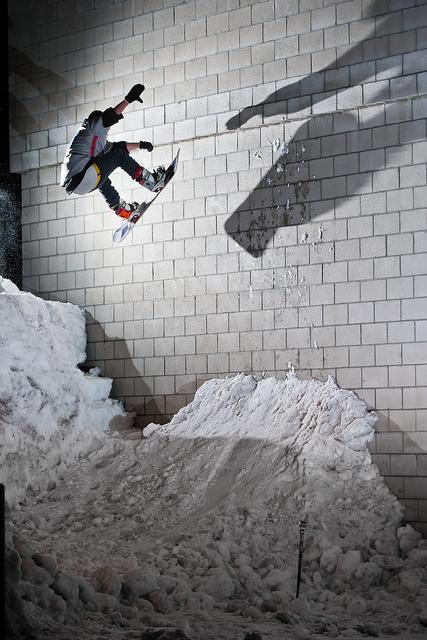Is the man going to crash into the wall?
Answer briefly. Yes. What sport is the person doing?
Concise answer only. Snowboarding. What's on the wall?
Quick response, please. Shadow. Is there loose gravel on the ground?
Be succinct. No. Can the man see his own shadow?
Keep it brief. Yes. What is in the picture?
Quick response, please. Snowboarder. Is the snow covering the wall?
Be succinct. Yes. What color is the coat of the person?
Keep it brief. White. 